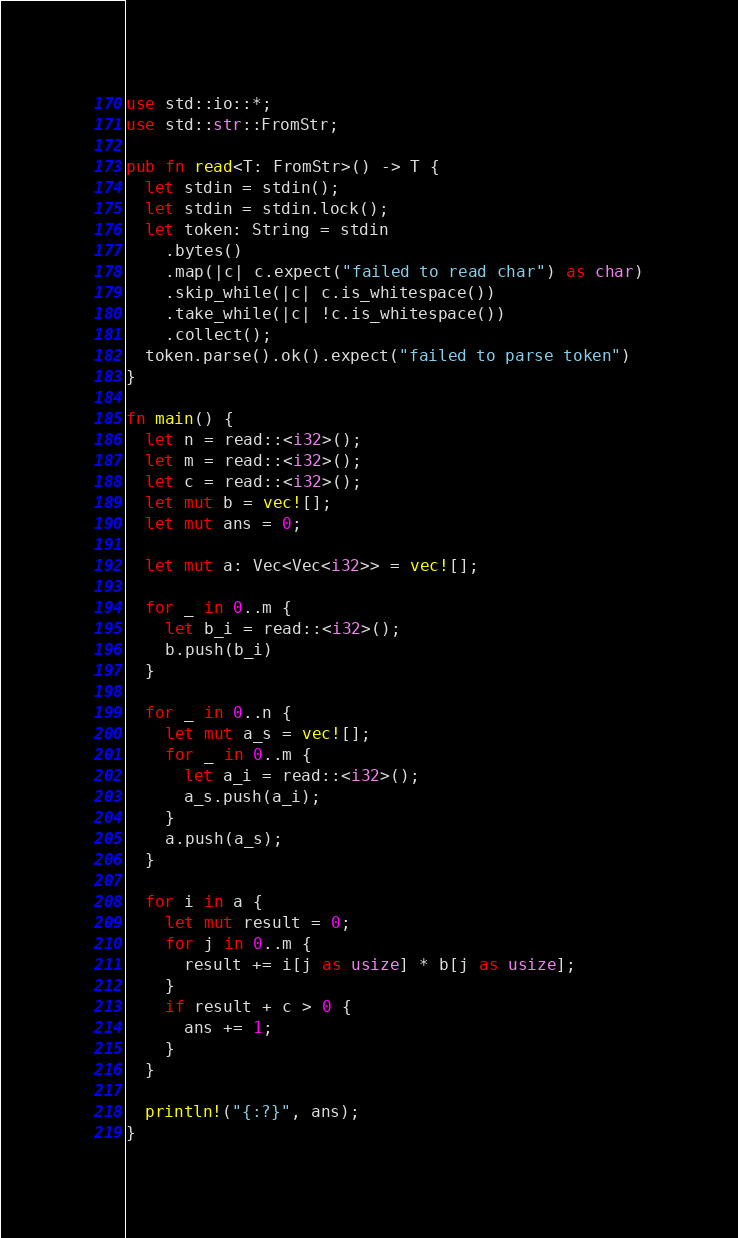<code> <loc_0><loc_0><loc_500><loc_500><_Rust_>use std::io::*;
use std::str::FromStr;

pub fn read<T: FromStr>() -> T {
  let stdin = stdin();
  let stdin = stdin.lock();
  let token: String = stdin
    .bytes()
    .map(|c| c.expect("failed to read char") as char)
    .skip_while(|c| c.is_whitespace())
    .take_while(|c| !c.is_whitespace())
    .collect();
  token.parse().ok().expect("failed to parse token")
}

fn main() {
  let n = read::<i32>();
  let m = read::<i32>();
  let c = read::<i32>();
  let mut b = vec![];
  let mut ans = 0;

  let mut a: Vec<Vec<i32>> = vec![];

  for _ in 0..m {
    let b_i = read::<i32>();
    b.push(b_i)
  }

  for _ in 0..n {
    let mut a_s = vec![];
    for _ in 0..m {
      let a_i = read::<i32>();
      a_s.push(a_i);
    }
    a.push(a_s);
  }

  for i in a {
    let mut result = 0;
    for j in 0..m {
      result += i[j as usize] * b[j as usize];
    }
    if result + c > 0 {
      ans += 1;
    }
  }

  println!("{:?}", ans);
}

</code> 